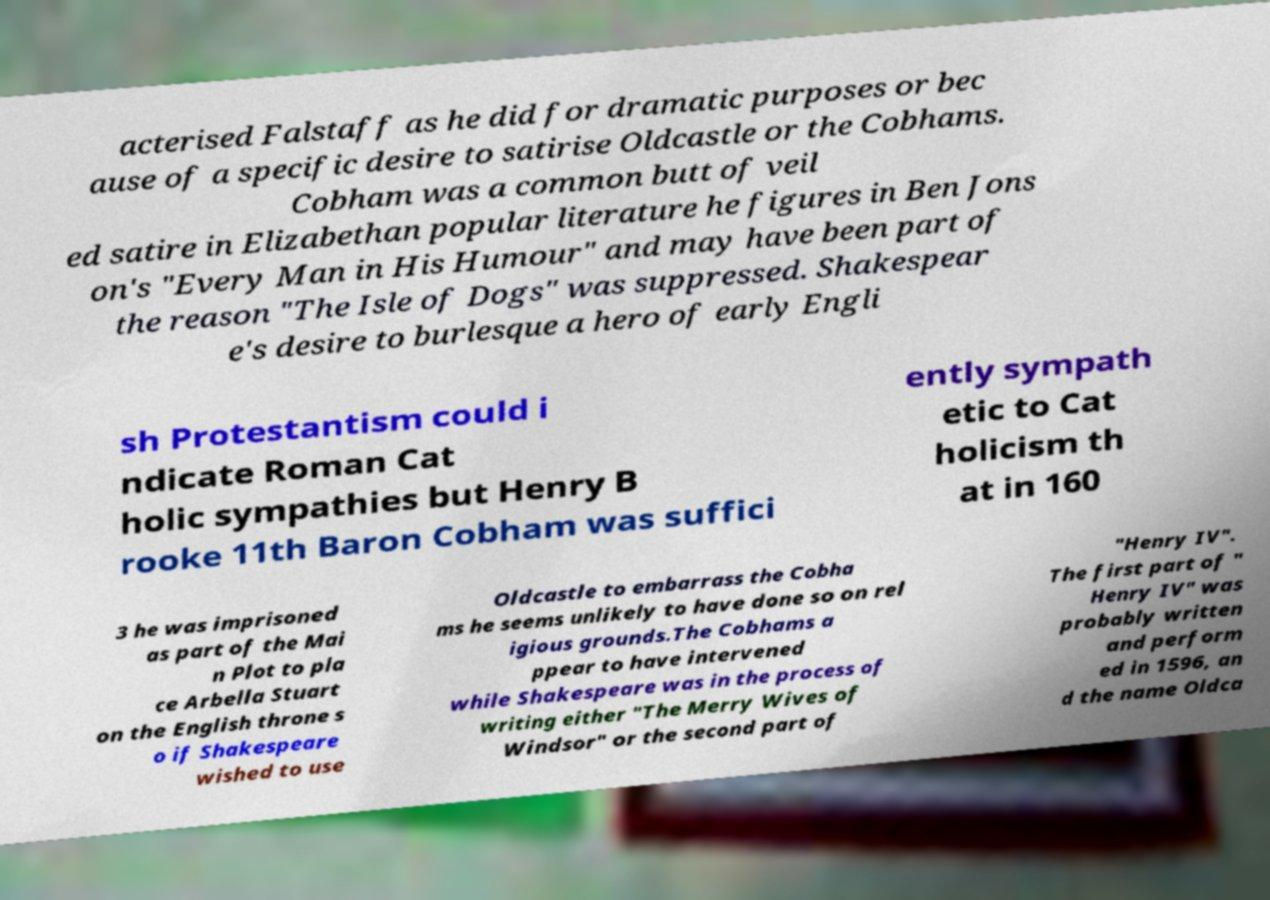For documentation purposes, I need the text within this image transcribed. Could you provide that? acterised Falstaff as he did for dramatic purposes or bec ause of a specific desire to satirise Oldcastle or the Cobhams. Cobham was a common butt of veil ed satire in Elizabethan popular literature he figures in Ben Jons on's "Every Man in His Humour" and may have been part of the reason "The Isle of Dogs" was suppressed. Shakespear e's desire to burlesque a hero of early Engli sh Protestantism could i ndicate Roman Cat holic sympathies but Henry B rooke 11th Baron Cobham was suffici ently sympath etic to Cat holicism th at in 160 3 he was imprisoned as part of the Mai n Plot to pla ce Arbella Stuart on the English throne s o if Shakespeare wished to use Oldcastle to embarrass the Cobha ms he seems unlikely to have done so on rel igious grounds.The Cobhams a ppear to have intervened while Shakespeare was in the process of writing either "The Merry Wives of Windsor" or the second part of "Henry IV". The first part of " Henry IV" was probably written and perform ed in 1596, an d the name Oldca 